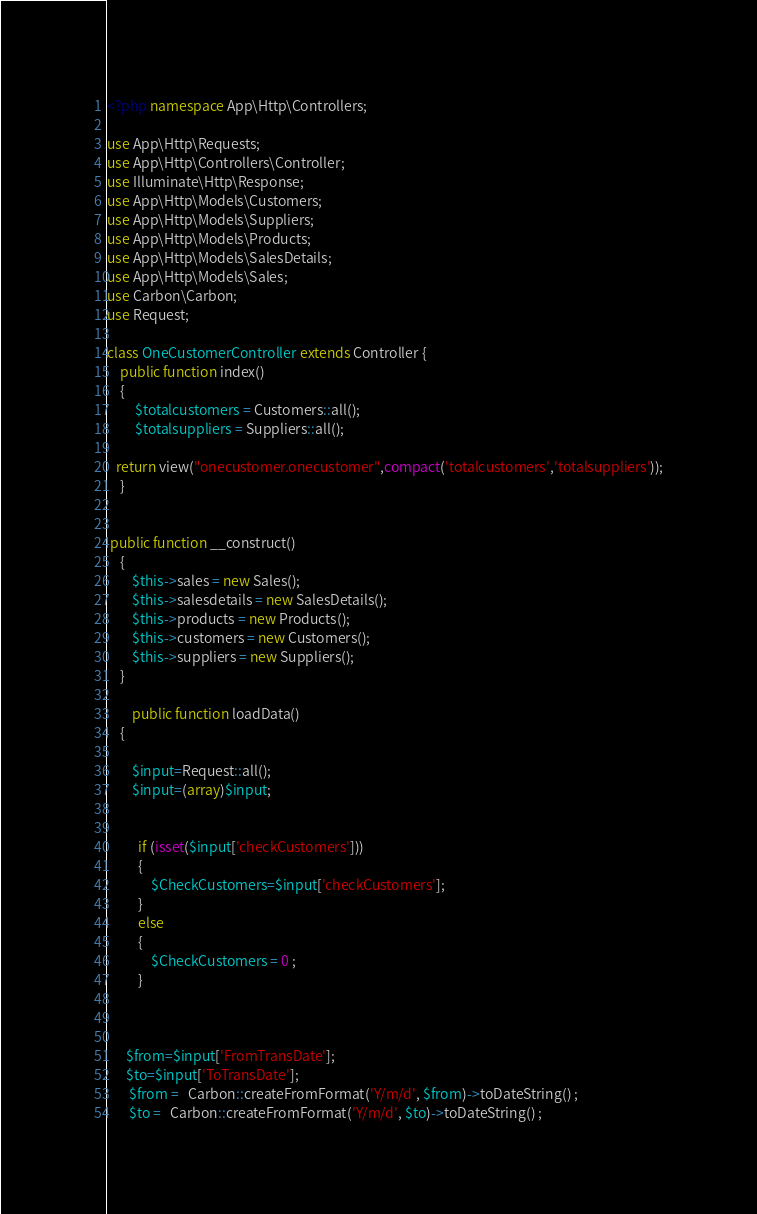Convert code to text. <code><loc_0><loc_0><loc_500><loc_500><_PHP_><?php namespace App\Http\Controllers;

use App\Http\Requests;
use App\Http\Controllers\Controller;
use Illuminate\Http\Response;
use App\Http\Models\Customers;
use App\Http\Models\Suppliers;
use App\Http\Models\Products;
use App\Http\Models\SalesDetails;
use App\Http\Models\Sales;
use Carbon\Carbon;
use Request;

class OneCustomerController extends Controller {
	public function index()
	{  
         $totalcustomers = Customers::all();
         $totalsuppliers = Suppliers::all();

   return view("onecustomer.onecustomer",compact('totalcustomers','totalsuppliers'));
	}


 public function __construct()
    {
        $this->sales = new Sales();
        $this->salesdetails = new SalesDetails();
        $this->products = new Products();
        $this->customers = new Customers();
		$this->suppliers = new Suppliers();
    }

	    public function loadData()
	{ 
         
        $input=Request::all();
        $input=(array)$input;
       
          
          if (isset($input['checkCustomers']))
          {
              $CheckCustomers=$input['checkCustomers'];
          }
          else
          {
              $CheckCustomers = 0 ;
          }
            

          
      $from=$input['FromTransDate'];
      $to=$input['ToTransDate'];
       $from =   Carbon::createFromFormat('Y/m/d', $from)->toDateString() ;
       $to =   Carbon::createFromFormat('Y/m/d', $to)->toDateString() ;</code> 